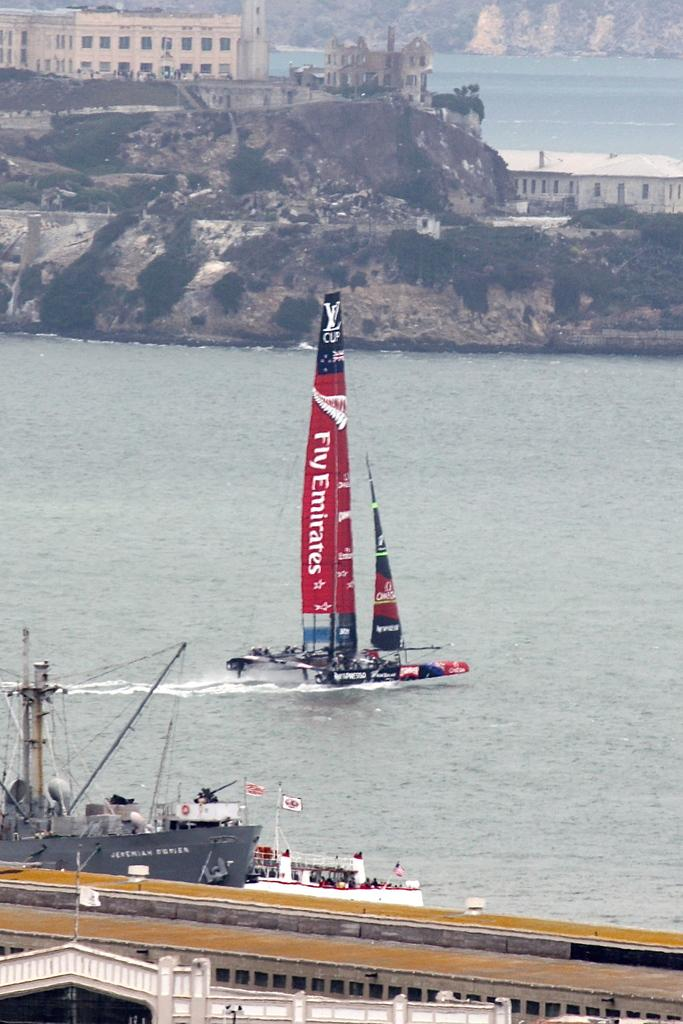What is located in the foreground of the image? There are boats in the foreground of the image. Where are the boats situated? The boats are in the water. What can be seen in the background of the image? There are trees, buildings, stones, and mountains in the background of the image. What might be the location of the image? The image may have been taken near the ocean. Can you tell me how many people are wearing hats in the image? There is no mention of hats or people wearing hats in the image, so it is not possible to answer that question. 